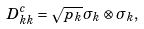<formula> <loc_0><loc_0><loc_500><loc_500>D _ { k k } ^ { c } = \sqrt { p _ { k } } \sigma _ { k } \otimes \sigma _ { k } ,</formula> 